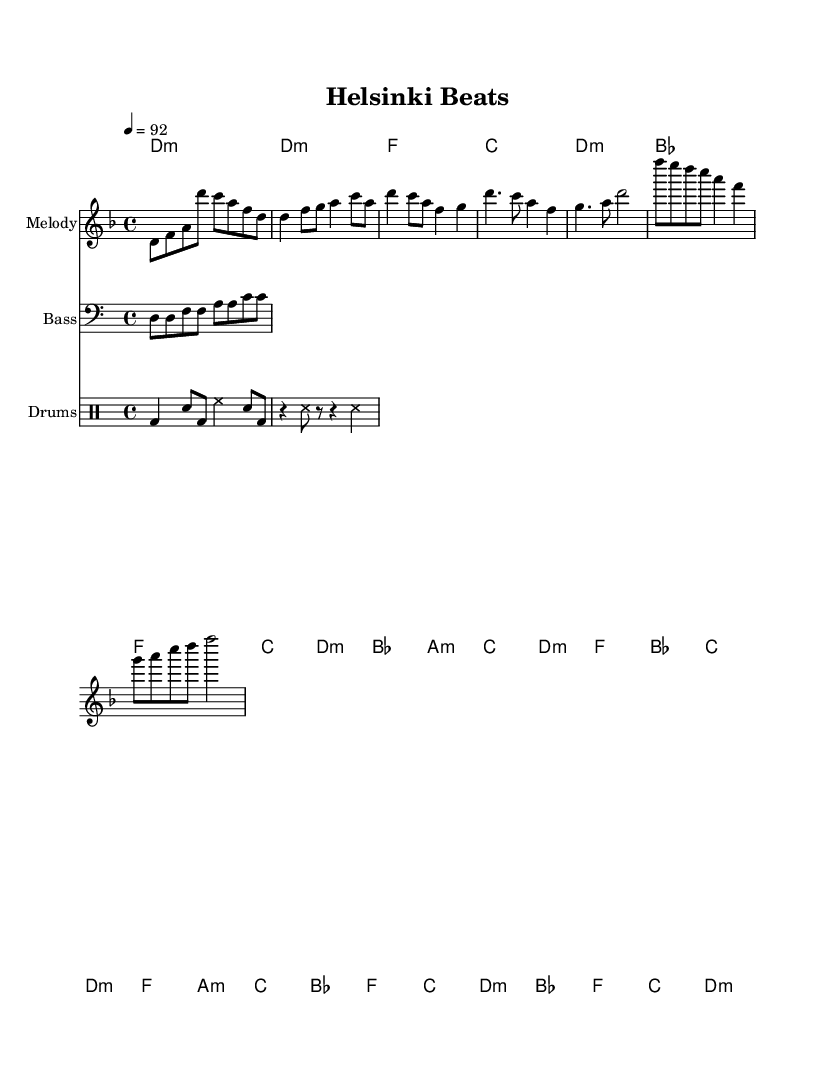What is the key signature of this music? The key signature is D minor, which is indicated by one flat (B♭). This can be confirmed by examining the key signature section at the beginning of the score.
Answer: D minor What is the time signature of this piece? The time signature is 4/4, as shown at the beginning of the score. This indicates that there are four beats in each measure and a quarter note receives one beat.
Answer: 4/4 What is the tempo marking for this music? The tempo is indicated as "4 = 92," meaning there are 92 beats per minute at a quarter note. This information is also found at the top of the score, alongside the time signature.
Answer: 92 How many measures are in the chorus section? The chorus section consists of 4 measures. By counting the individual measures between the melody and harmonies during the chorus, we can confirm it has 4 distinct measures.
Answer: 4 What type of rhythmic pattern is used for the drums? The drum pattern includes a combination of bass drum, snare drum, and hi-hat, which is typical in hip-hop music. Looking at the drum notation reveals a recognizable pattern involving different drum hits and rests.
Answer: Bass, Snare, Hi-hat What is the relationship between the melody and harmonies in the verse? The melody in the verse features notes that typically align with the harmony chords being played. By examining the notes in the melody and the corresponding harmonic structure, one can see that they work harmoniously together, reflecting a common practice in songwriting.
Answer: Harmonious What classical music element is reflected in this hip-hop piece? The piece incorporates classical music through its use of classical chordal harmonies and melodic structures, indicating a blend of genres. The presence of traditional classical patterns within the hip-hop framework showcases this fusion.
Answer: Classical Harmonies 